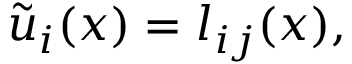Convert formula to latex. <formula><loc_0><loc_0><loc_500><loc_500>\tilde { u } _ { i } ( x ) = l _ { i j } ( x ) ,</formula> 